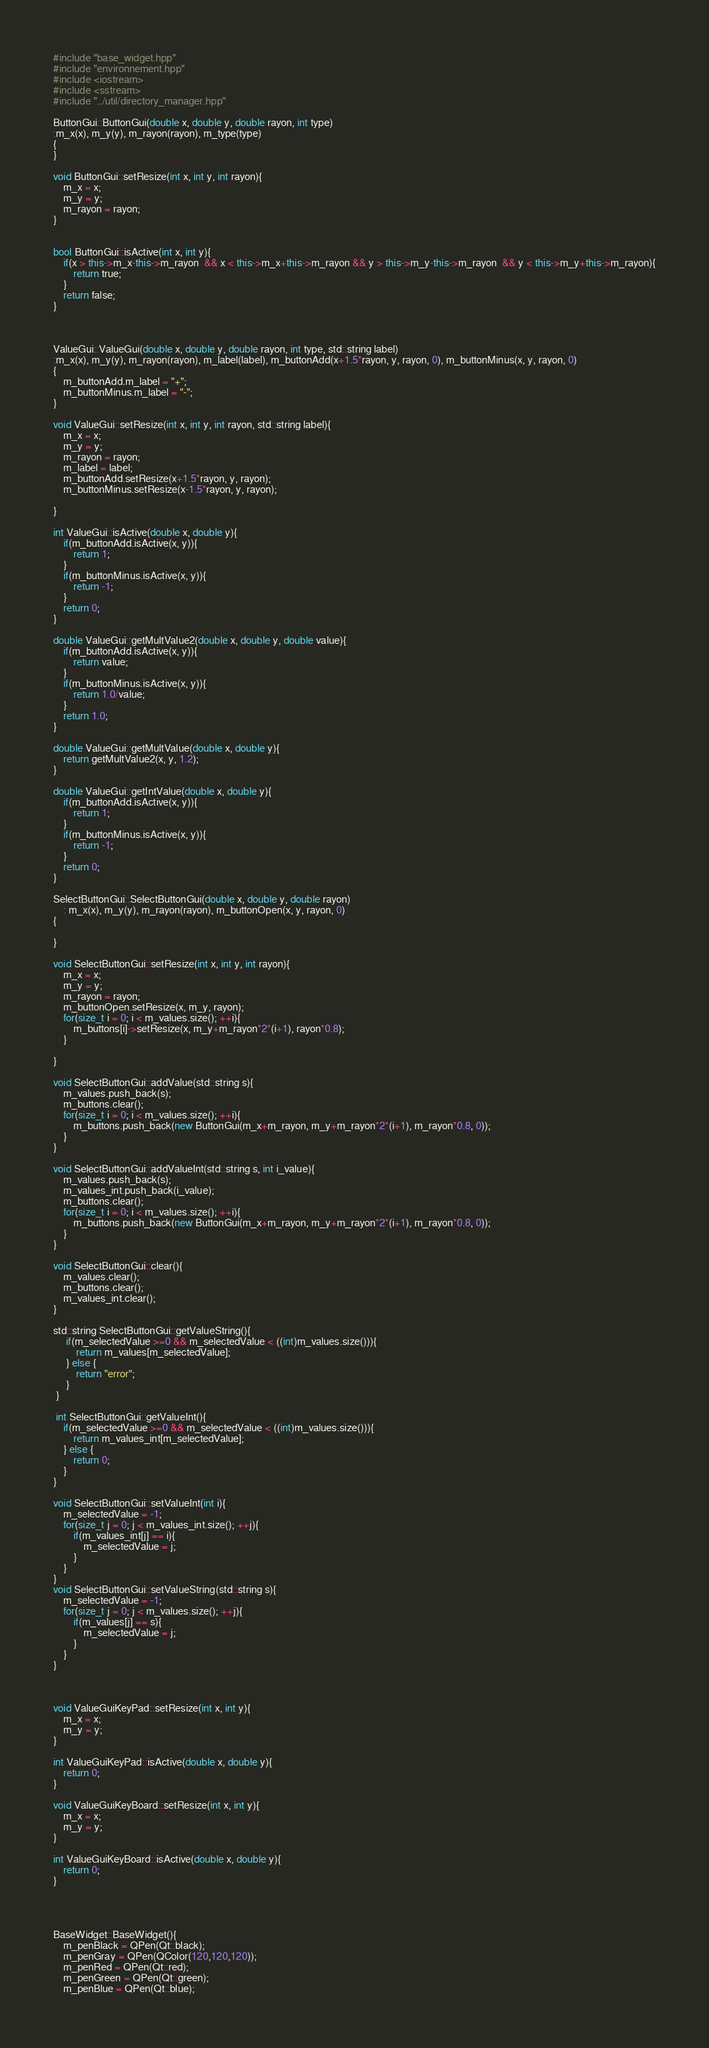<code> <loc_0><loc_0><loc_500><loc_500><_C++_>#include "base_widget.hpp"
#include "environnement.hpp"
#include <iostream>
#include <sstream>
#include "../util/directory_manager.hpp"

ButtonGui::ButtonGui(double x, double y, double rayon, int type)
:m_x(x), m_y(y), m_rayon(rayon), m_type(type)
{
}

void ButtonGui::setResize(int x, int y, int rayon){
    m_x = x;
    m_y = y;
    m_rayon = rayon;
}


bool ButtonGui::isActive(int x, int y){
    if(x > this->m_x-this->m_rayon  && x < this->m_x+this->m_rayon && y > this->m_y-this->m_rayon  && y < this->m_y+this->m_rayon){
        return true;
    }
    return false;
}



ValueGui::ValueGui(double x, double y, double rayon, int type, std::string label)
:m_x(x), m_y(y), m_rayon(rayon), m_label(label), m_buttonAdd(x+1.5*rayon, y, rayon, 0), m_buttonMinus(x, y, rayon, 0)
{
    m_buttonAdd.m_label = "+";
    m_buttonMinus.m_label = "-";
}

void ValueGui::setResize(int x, int y, int rayon, std::string label){
    m_x = x;
    m_y = y;
    m_rayon = rayon;
    m_label = label;
    m_buttonAdd.setResize(x+1.5*rayon, y, rayon);
    m_buttonMinus.setResize(x-1.5*rayon, y, rayon);
    
}

int ValueGui::isActive(double x, double y){
    if(m_buttonAdd.isActive(x, y)){
        return 1;
    }
    if(m_buttonMinus.isActive(x, y)){
        return -1;
    }
    return 0;
}

double ValueGui::getMultValue2(double x, double y, double value){
    if(m_buttonAdd.isActive(x, y)){
        return value;
    }
    if(m_buttonMinus.isActive(x, y)){
        return 1.0/value;
    }
    return 1.0;
}

double ValueGui::getMultValue(double x, double y){
    return getMultValue2(x, y, 1.2);
}

double ValueGui::getIntValue(double x, double y){
    if(m_buttonAdd.isActive(x, y)){
        return 1;
    }
    if(m_buttonMinus.isActive(x, y)){
        return -1;
    }
    return 0;
}

SelectButtonGui::SelectButtonGui(double x, double y, double rayon)
    : m_x(x), m_y(y), m_rayon(rayon), m_buttonOpen(x, y, rayon, 0)
{
    
}

void SelectButtonGui::setResize(int x, int y, int rayon){
    m_x = x;
    m_y = y;
    m_rayon = rayon;
    m_buttonOpen.setResize(x, m_y, rayon);
    for(size_t i = 0; i < m_values.size(); ++i){
        m_buttons[i]->setResize(x, m_y+m_rayon*2*(i+1), rayon*0.8);
    }
    
}

void SelectButtonGui::addValue(std::string s){
    m_values.push_back(s);
    m_buttons.clear();
    for(size_t i = 0; i < m_values.size(); ++i){
        m_buttons.push_back(new ButtonGui(m_x+m_rayon, m_y+m_rayon*2*(i+1), m_rayon*0.8, 0));
    }
}

void SelectButtonGui::addValueInt(std::string s, int i_value){
    m_values.push_back(s);
    m_values_int.push_back(i_value);
    m_buttons.clear();
    for(size_t i = 0; i < m_values.size(); ++i){
        m_buttons.push_back(new ButtonGui(m_x+m_rayon, m_y+m_rayon*2*(i+1), m_rayon*0.8, 0));
    }
}

void SelectButtonGui::clear(){
    m_values.clear();
    m_buttons.clear();
    m_values_int.clear();
}

std::string SelectButtonGui::getValueString(){
     if(m_selectedValue >=0 && m_selectedValue < ((int)m_values.size())){
         return m_values[m_selectedValue];
     } else {
         return "error";
     }
 }
 
 int SelectButtonGui::getValueInt(){
    if(m_selectedValue >=0 && m_selectedValue < ((int)m_values.size())){
        return m_values_int[m_selectedValue];
    } else {
        return 0;
    }
}
 
void SelectButtonGui::setValueInt(int i){
    m_selectedValue = -1;
    for(size_t j = 0; j < m_values_int.size(); ++j){
        if(m_values_int[j] == i){
            m_selectedValue = j;
        }
    }
}
void SelectButtonGui::setValueString(std::string s){
    m_selectedValue = -1;
    for(size_t j = 0; j < m_values.size(); ++j){
        if(m_values[j] == s){
            m_selectedValue = j;
        }
    }
}



void ValueGuiKeyPad::setResize(int x, int y){
    m_x = x;
    m_y = y;
}

int ValueGuiKeyPad::isActive(double x, double y){
    return 0;
}

void ValueGuiKeyBoard::setResize(int x, int y){
    m_x = x;
    m_y = y;
}

int ValueGuiKeyBoard::isActive(double x, double y){
    return 0;
}




BaseWidget::BaseWidget(){
    m_penBlack = QPen(Qt::black);
    m_penGray = QPen(QColor(120,120,120));
    m_penRed = QPen(Qt::red);
    m_penGreen = QPen(Qt::green);
    m_penBlue = QPen(Qt::blue);</code> 